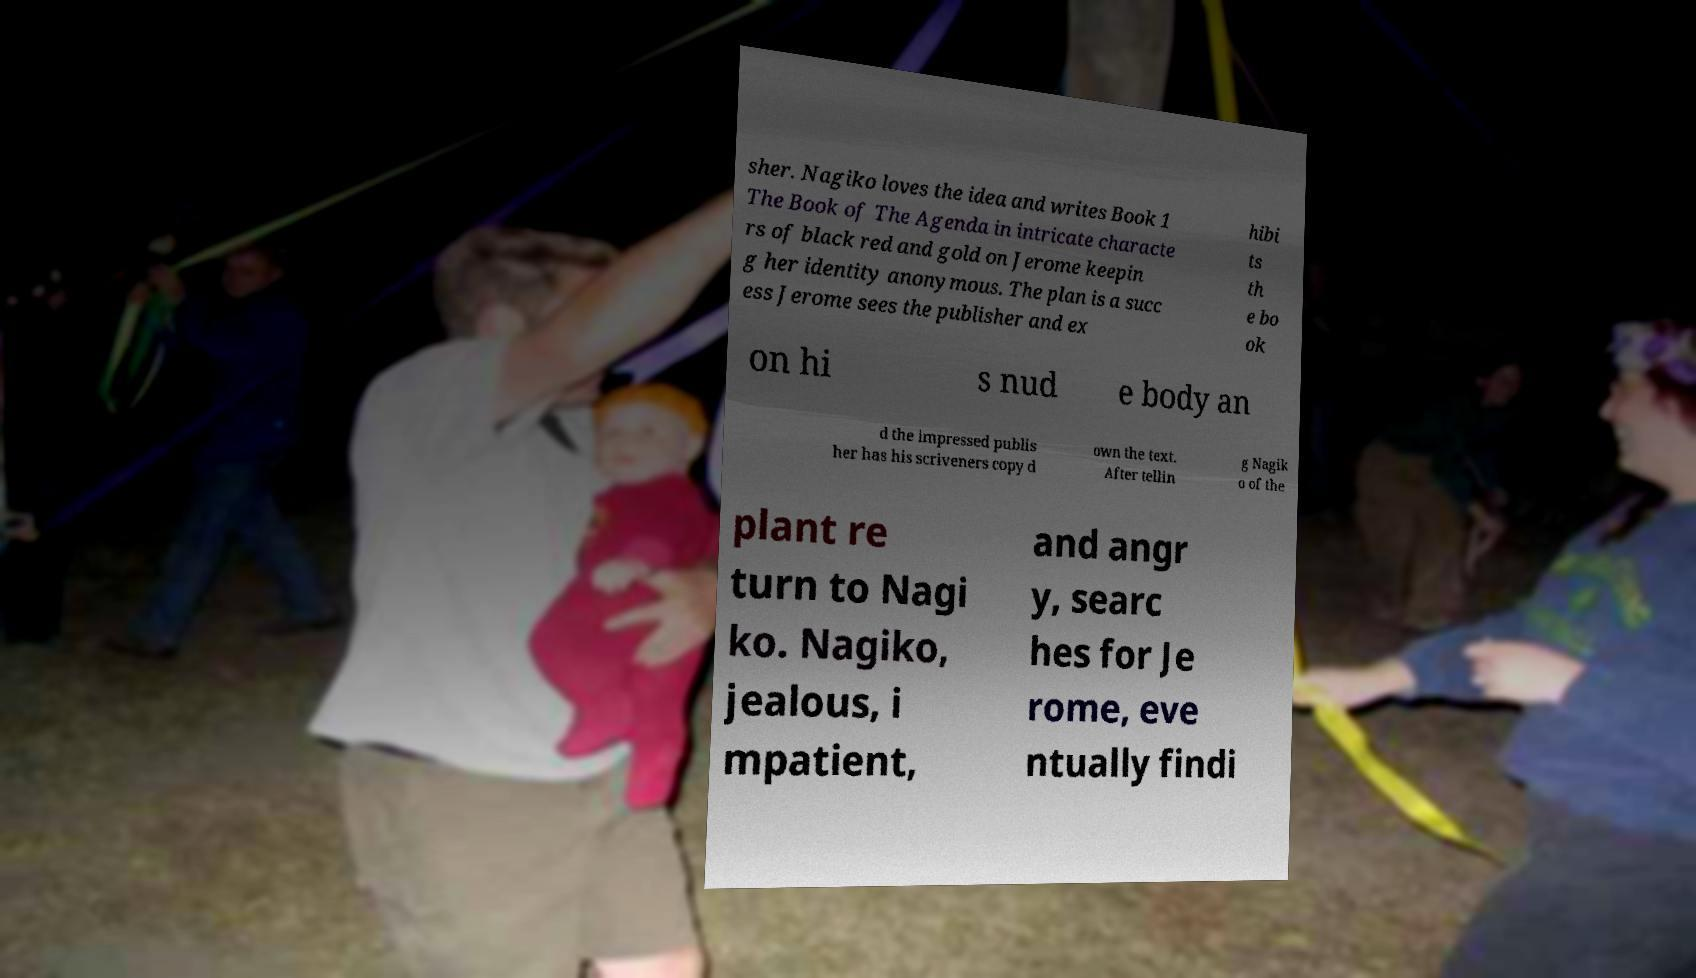Could you assist in decoding the text presented in this image and type it out clearly? sher. Nagiko loves the idea and writes Book 1 The Book of The Agenda in intricate characte rs of black red and gold on Jerome keepin g her identity anonymous. The plan is a succ ess Jerome sees the publisher and ex hibi ts th e bo ok on hi s nud e body an d the impressed publis her has his scriveners copy d own the text. After tellin g Nagik o of the plant re turn to Nagi ko. Nagiko, jealous, i mpatient, and angr y, searc hes for Je rome, eve ntually findi 